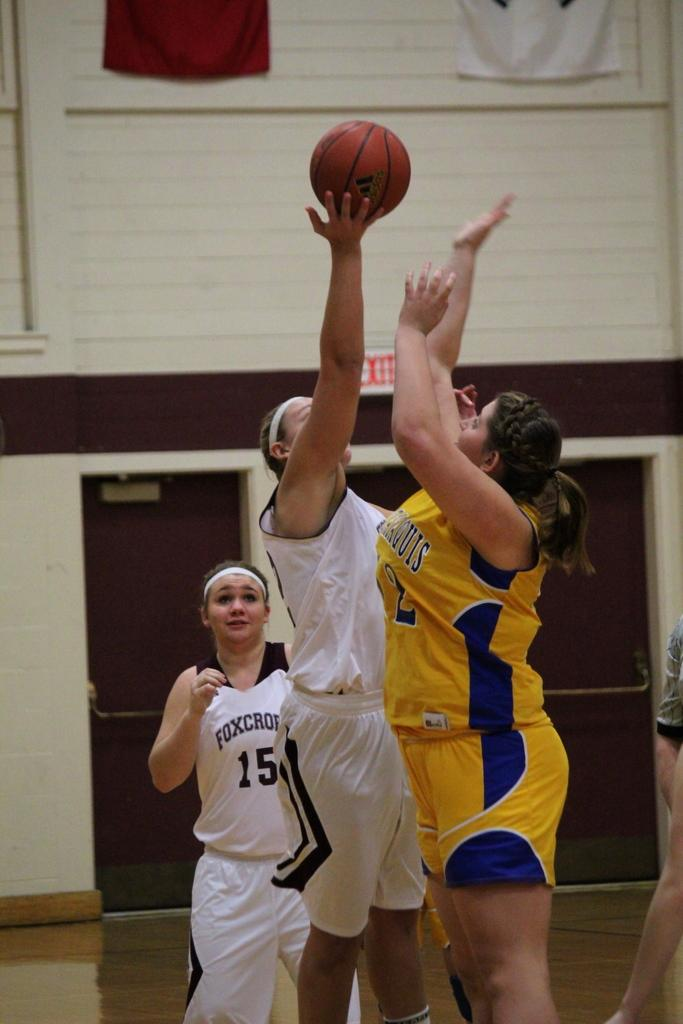<image>
Present a compact description of the photo's key features. A trio of girls are playing basketball with one having 15 on her shirt standing in front of an EXIT sign. 